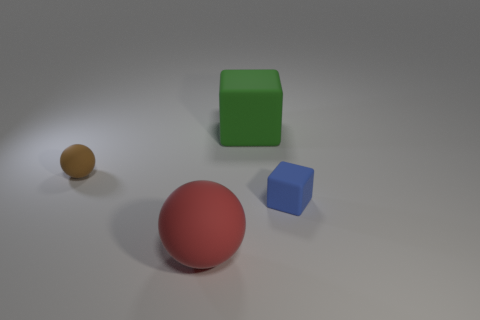Add 3 big yellow metallic objects. How many objects exist? 7 Subtract all small shiny things. Subtract all small matte spheres. How many objects are left? 3 Add 4 red matte balls. How many red matte balls are left? 5 Add 4 large matte balls. How many large matte balls exist? 5 Subtract 0 yellow blocks. How many objects are left? 4 